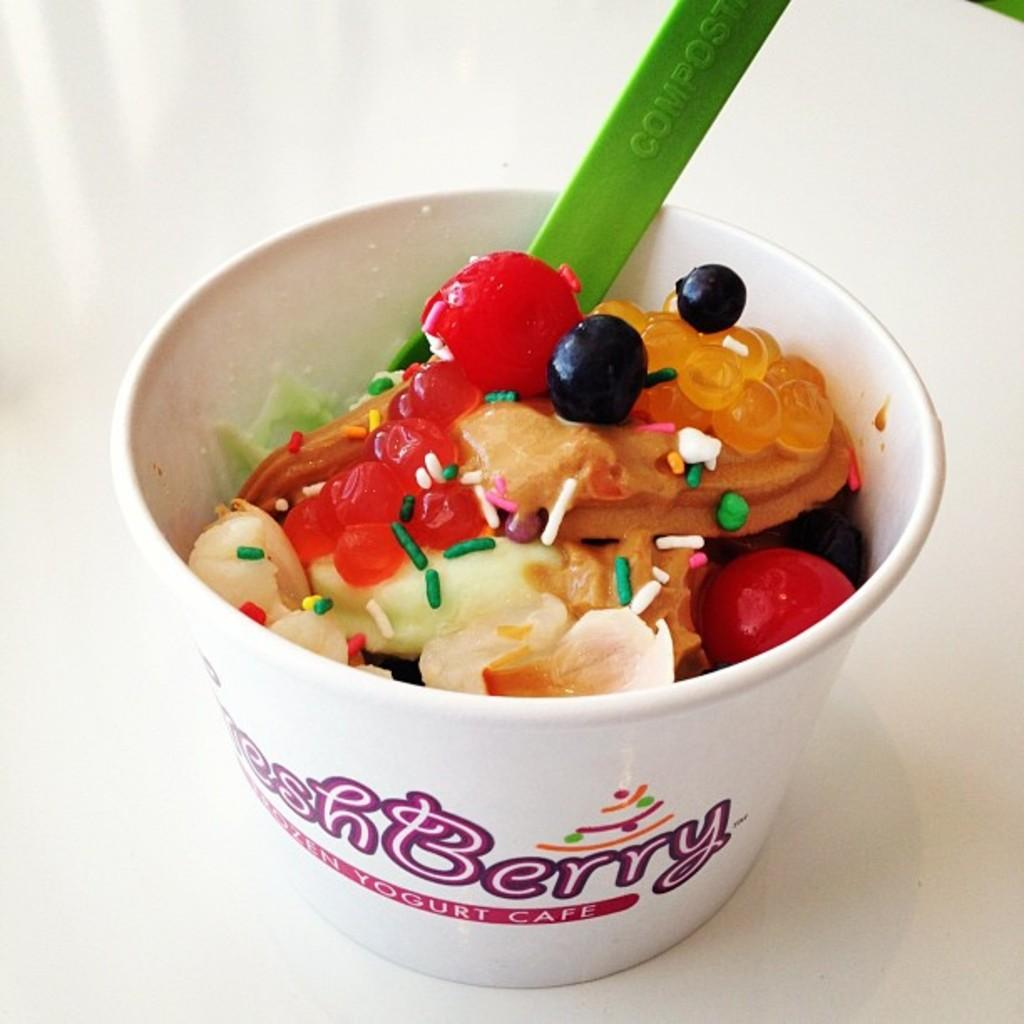What object is present on the white surface in the image? There is a cup on a white surface in the image. What can be seen on the cup? There is writing on the cup. What is inside the cup? There is a food item inside the cup. What color is the spoon in the image? There is a green spoon in the image. What type of offer is being made on the stage in the image? There is no stage or offer present in the image; it only features a cup, writing on the cup, a food item inside the cup, and a green spoon. 